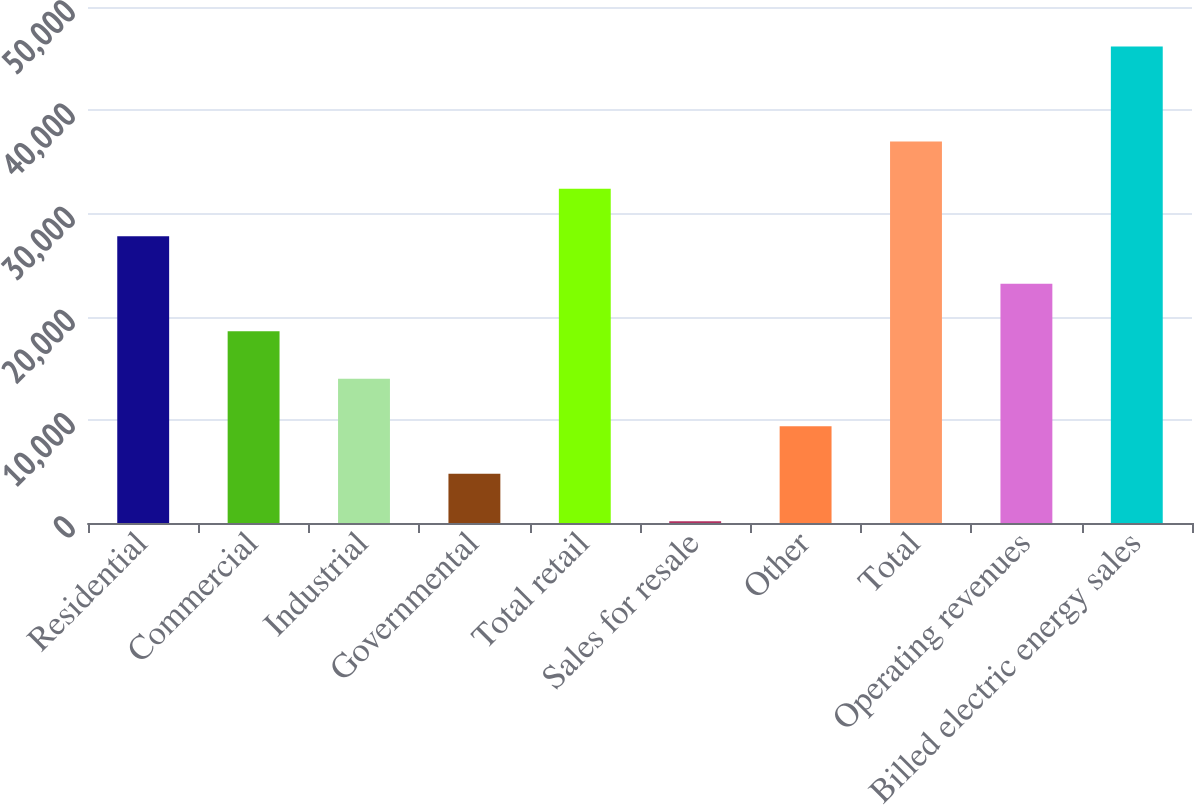<chart> <loc_0><loc_0><loc_500><loc_500><bar_chart><fcel>Residential<fcel>Commercial<fcel>Industrial<fcel>Governmental<fcel>Total retail<fcel>Sales for resale<fcel>Other<fcel>Total<fcel>Operating revenues<fcel>Billed electric energy sales<nl><fcel>27778.4<fcel>18578.6<fcel>13978.7<fcel>4778.9<fcel>32378.3<fcel>179<fcel>9378.8<fcel>36978.2<fcel>23178.5<fcel>46178<nl></chart> 